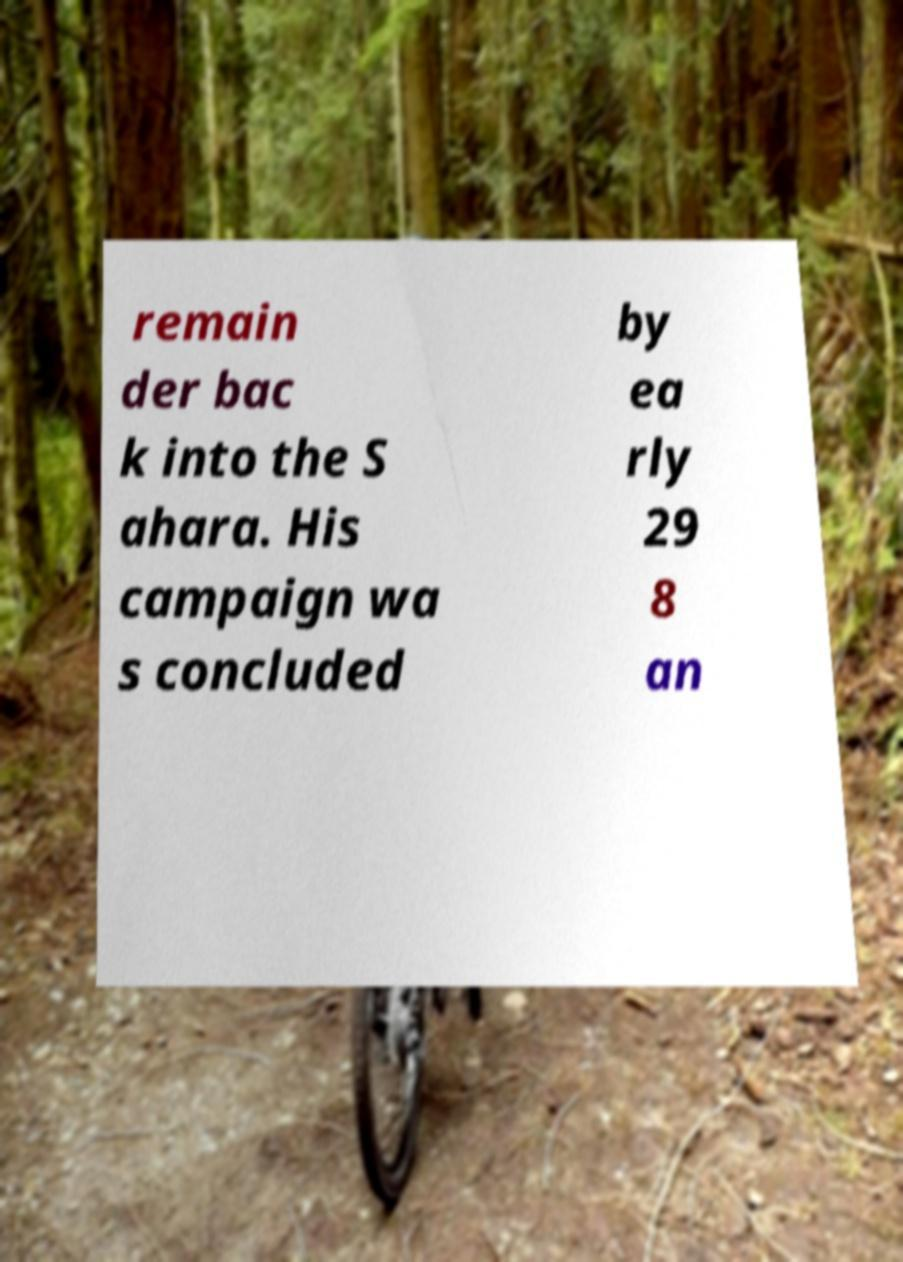Could you extract and type out the text from this image? remain der bac k into the S ahara. His campaign wa s concluded by ea rly 29 8 an 